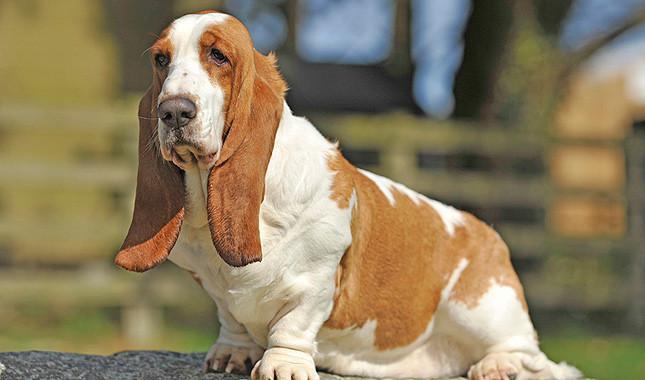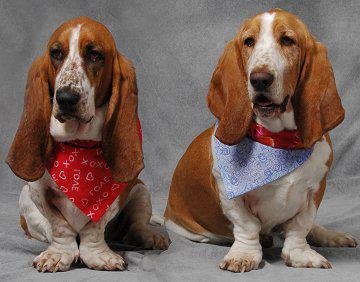The first image is the image on the left, the second image is the image on the right. Considering the images on both sides, is "There are at least seven dogs." valid? Answer yes or no. No. 